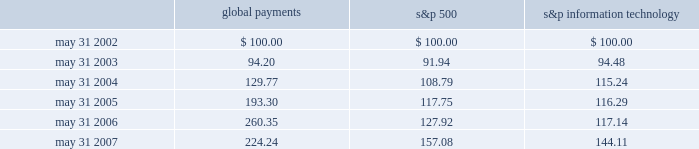Stock performance graph the following line-graph presentation compares our cumulative shareholder returns with the standard & poor 2019s information technology index and the standard & poor 2019s 500 stock index for the past five years .
The line graph assumes the investment of $ 100 in our common stock , the standard & poor 2019s information technology index , and the standard & poor 2019s 500 stock index on may 31 , 2002 and assumes reinvestment of all dividends .
Comparison of 5 year cumulative total return* among global payments inc. , the s&p 500 index and the s&p information technology index 5/02 5/03 5/04 5/05 5/06 5/07 global payments inc .
S&p 500 s&p information technology * $ 100 invested on 5/31/02 in stock or index-including reinvestment of dividends .
Fiscal year ending may 31 .
Global payments s&p 500 information technology .
Issuer purchases of equity securities on april 5 , 2007 , our board of directors authorized repurchases of our common stock in an amount up to $ 100 million .
The board has authorized us to purchase shares from time to time as market conditions permit .
There is no expiration date with respect to this authorization .
No amounts have been repurchased during the fiscal year ended may 31 , 2007. .
What will be the rate of return for global payments from 2002 to 2003? 
Computations: ((94.20 - 100) / 100)
Answer: -0.058. Stock performance graph the following line-graph presentation compares our cumulative shareholder returns with the standard & poor 2019s information technology index and the standard & poor 2019s 500 stock index for the past five years .
The line graph assumes the investment of $ 100 in our common stock , the standard & poor 2019s information technology index , and the standard & poor 2019s 500 stock index on may 31 , 2002 and assumes reinvestment of all dividends .
Comparison of 5 year cumulative total return* among global payments inc. , the s&p 500 index and the s&p information technology index 5/02 5/03 5/04 5/05 5/06 5/07 global payments inc .
S&p 500 s&p information technology * $ 100 invested on 5/31/02 in stock or index-including reinvestment of dividends .
Fiscal year ending may 31 .
Global payments s&p 500 information technology .
Issuer purchases of equity securities on april 5 , 2007 , our board of directors authorized repurchases of our common stock in an amount up to $ 100 million .
The board has authorized us to purchase shares from time to time as market conditions permit .
There is no expiration date with respect to this authorization .
No amounts have been repurchased during the fiscal year ended may 31 , 2007. .
What will be the rate of return for global payments from 2003 to 2004? 
Computations: ((129.77 - 94.20) / 94.20)
Answer: 0.3776. 